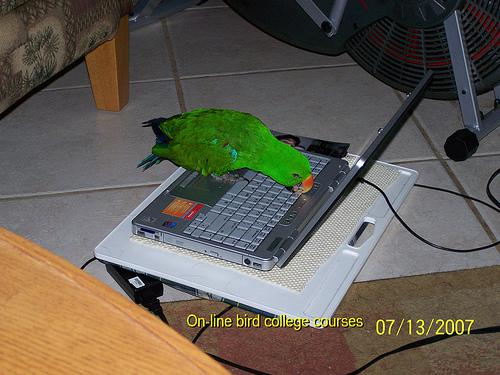Question: where is the bird?
Choices:
A. On the branch.
B. On the windowsill.
C. On the sand.
D. On the laptop.
Answer with the letter. Answer: D Question: what color is the parrot?
Choices:
A. Red.
B. Green.
C. Blue.
D. Yellow.
Answer with the letter. Answer: B Question: where is the parrot?
Choices:
A. On the cage.
B. On the bed.
C. On the laptop.
D. Flying in the air.
Answer with the letter. Answer: C Question: what is on the laptop?
Choices:
A. A bowl.
B. A towel.
C. A bird.
D. Plastic bag.
Answer with the letter. Answer: C Question: what color is the laptop?
Choices:
A. Silver.
B. Black.
C. Blue.
D. Tan.
Answer with the letter. Answer: A Question: what is on the floor?
Choices:
A. Tile.
B. Wood.
C. Ceramic.
D. Glass.
Answer with the letter. Answer: A 